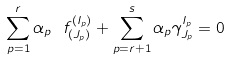<formula> <loc_0><loc_0><loc_500><loc_500>\sum _ { p = 1 } ^ { r } \alpha _ { p } \ f ^ { ( I _ { p } ) } _ { ( J _ { p } ) } + \sum _ { p = r + 1 } ^ { s } \alpha _ { p } \gamma ^ { I _ { p } } _ { J _ { p } } = 0</formula> 